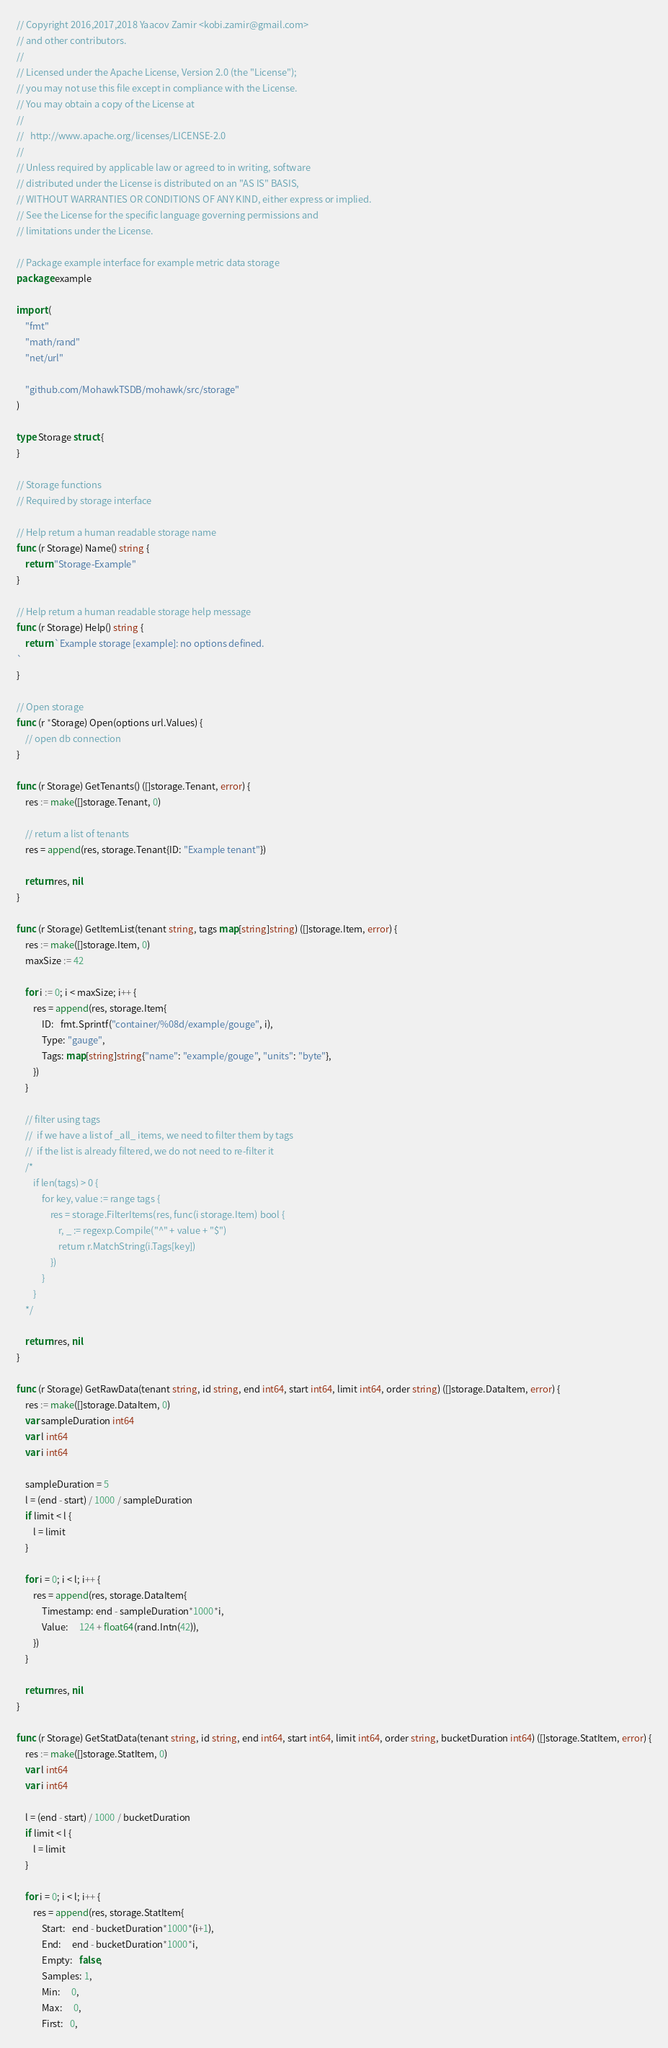Convert code to text. <code><loc_0><loc_0><loc_500><loc_500><_Go_>// Copyright 2016,2017,2018 Yaacov Zamir <kobi.zamir@gmail.com>
// and other contributors.
//
// Licensed under the Apache License, Version 2.0 (the "License");
// you may not use this file except in compliance with the License.
// You may obtain a copy of the License at
//
//   http://www.apache.org/licenses/LICENSE-2.0
//
// Unless required by applicable law or agreed to in writing, software
// distributed under the License is distributed on an "AS IS" BASIS,
// WITHOUT WARRANTIES OR CONDITIONS OF ANY KIND, either express or implied.
// See the License for the specific language governing permissions and
// limitations under the License.

// Package example interface for example metric data storage
package example

import (
	"fmt"
	"math/rand"
	"net/url"

	"github.com/MohawkTSDB/mohawk/src/storage"
)

type Storage struct {
}

// Storage functions
// Required by storage interface

// Help return a human readable storage name
func (r Storage) Name() string {
	return "Storage-Example"
}

// Help return a human readable storage help message
func (r Storage) Help() string {
	return `Example storage [example]: no options defined.
`
}

// Open storage
func (r *Storage) Open(options url.Values) {
	// open db connection
}

func (r Storage) GetTenants() ([]storage.Tenant, error) {
	res := make([]storage.Tenant, 0)

	// return a list of tenants
	res = append(res, storage.Tenant{ID: "Example tenant"})

	return res, nil
}

func (r Storage) GetItemList(tenant string, tags map[string]string) ([]storage.Item, error) {
	res := make([]storage.Item, 0)
	maxSize := 42

	for i := 0; i < maxSize; i++ {
		res = append(res, storage.Item{
			ID:   fmt.Sprintf("container/%08d/example/gouge", i),
			Type: "gauge",
			Tags: map[string]string{"name": "example/gouge", "units": "byte"},
		})
	}

	// filter using tags
	// 	if we have a list of _all_ items, we need to filter them by tags
	// 	if the list is already filtered, we do not need to re-filter it
	/*
		if len(tags) > 0 {
			for key, value := range tags {
				res = storage.FilterItems(res, func(i storage.Item) bool {
					r, _ := regexp.Compile("^" + value + "$")
					return r.MatchString(i.Tags[key])
				})
			}
		}
	*/

	return res, nil
}

func (r Storage) GetRawData(tenant string, id string, end int64, start int64, limit int64, order string) ([]storage.DataItem, error) {
	res := make([]storage.DataItem, 0)
	var sampleDuration int64
	var l int64
	var i int64

	sampleDuration = 5
	l = (end - start) / 1000 / sampleDuration
	if limit < l {
		l = limit
	}

	for i = 0; i < l; i++ {
		res = append(res, storage.DataItem{
			Timestamp: end - sampleDuration*1000*i,
			Value:     124 + float64(rand.Intn(42)),
		})
	}

	return res, nil
}

func (r Storage) GetStatData(tenant string, id string, end int64, start int64, limit int64, order string, bucketDuration int64) ([]storage.StatItem, error) {
	res := make([]storage.StatItem, 0)
	var l int64
	var i int64

	l = (end - start) / 1000 / bucketDuration
	if limit < l {
		l = limit
	}

	for i = 0; i < l; i++ {
		res = append(res, storage.StatItem{
			Start:   end - bucketDuration*1000*(i+1),
			End:     end - bucketDuration*1000*i,
			Empty:   false,
			Samples: 1,
			Min:     0,
			Max:     0,
			First:   0,</code> 